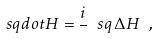<formula> <loc_0><loc_0><loc_500><loc_500>\ s q d o t H = \frac { i } { } \ s q \, \Delta H \ ,</formula> 